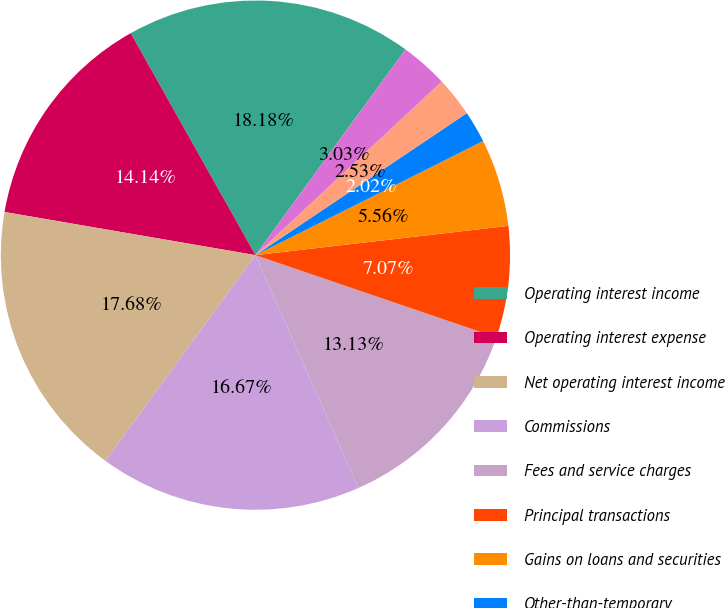Convert chart to OTSL. <chart><loc_0><loc_0><loc_500><loc_500><pie_chart><fcel>Operating interest income<fcel>Operating interest expense<fcel>Net operating interest income<fcel>Commissions<fcel>Fees and service charges<fcel>Principal transactions<fcel>Gains on loans and securities<fcel>Other-than-temporary<fcel>Less noncredit portion of OTTI<fcel>Net impairment<nl><fcel>18.18%<fcel>14.14%<fcel>17.68%<fcel>16.67%<fcel>13.13%<fcel>7.07%<fcel>5.56%<fcel>2.02%<fcel>2.53%<fcel>3.03%<nl></chart> 